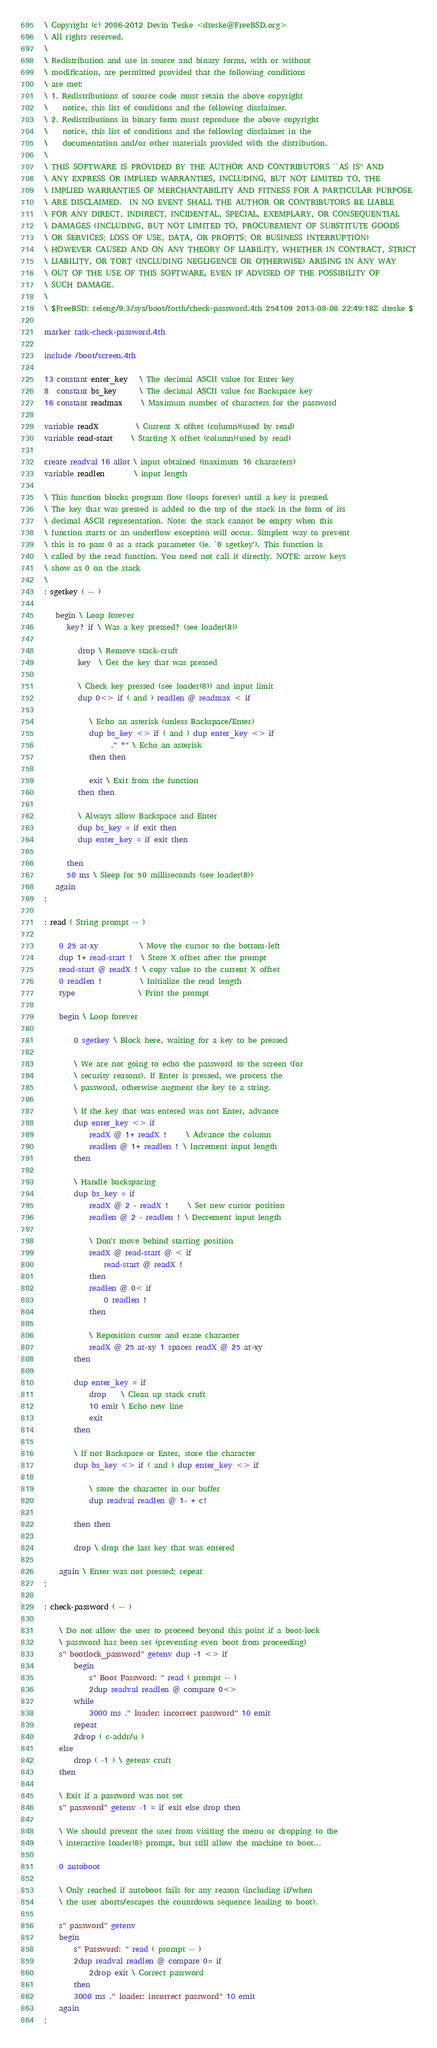Convert code to text. <code><loc_0><loc_0><loc_500><loc_500><_Forth_>\ Copyright (c) 2006-2012 Devin Teske <dteske@FreeBSD.org>
\ All rights reserved.
\ 
\ Redistribution and use in source and binary forms, with or without
\ modification, are permitted provided that the following conditions
\ are met:
\ 1. Redistributions of source code must retain the above copyright
\    notice, this list of conditions and the following disclaimer.
\ 2. Redistributions in binary form must reproduce the above copyright
\    notice, this list of conditions and the following disclaimer in the
\    documentation and/or other materials provided with the distribution.
\ 
\ THIS SOFTWARE IS PROVIDED BY THE AUTHOR AND CONTRIBUTORS ``AS IS'' AND
\ ANY EXPRESS OR IMPLIED WARRANTIES, INCLUDING, BUT NOT LIMITED TO, THE
\ IMPLIED WARRANTIES OF MERCHANTABILITY AND FITNESS FOR A PARTICULAR PURPOSE
\ ARE DISCLAIMED.  IN NO EVENT SHALL THE AUTHOR OR CONTRIBUTORS BE LIABLE
\ FOR ANY DIRECT, INDIRECT, INCIDENTAL, SPECIAL, EXEMPLARY, OR CONSEQUENTIAL
\ DAMAGES (INCLUDING, BUT NOT LIMITED TO, PROCUREMENT OF SUBSTITUTE GOODS
\ OR SERVICES; LOSS OF USE, DATA, OR PROFITS; OR BUSINESS INTERRUPTION)
\ HOWEVER CAUSED AND ON ANY THEORY OF LIABILITY, WHETHER IN CONTRACT, STRICT
\ LIABILITY, OR TORT (INCLUDING NEGLIGENCE OR OTHERWISE) ARISING IN ANY WAY
\ OUT OF THE USE OF THIS SOFTWARE, EVEN IF ADVISED OF THE POSSIBILITY OF
\ SUCH DAMAGE.
\ 
\ $FreeBSD: releng/9.3/sys/boot/forth/check-password.4th 254109 2013-08-08 22:49:18Z dteske $

marker task-check-password.4th

include /boot/screen.4th

13 constant enter_key   \ The decimal ASCII value for Enter key
8  constant bs_key      \ The decimal ASCII value for Backspace key
16 constant readmax     \ Maximum number of characters for the password

variable readX          \ Current X offset (column)(used by read)
variable read-start     \ Starting X offset (column)(used by read)

create readval 16 allot \ input obtained (maximum 16 characters)
variable readlen        \ input length

\ This function blocks program flow (loops forever) until a key is pressed.
\ The key that was pressed is added to the top of the stack in the form of its
\ decimal ASCII representation. Note: the stack cannot be empty when this
\ function starts or an underflow exception will occur. Simplest way to prevent
\ this is to pass 0 as a stack parameter (ie. `0 sgetkey'). This function is
\ called by the read function. You need not call it directly. NOTE: arrow keys
\ show as 0 on the stack
\ 
: sgetkey ( -- )

   begin \ Loop forever
      key? if \ Was a key pressed? (see loader(8))

         drop \ Remove stack-cruft
         key  \ Get the key that was pressed

         \ Check key pressed (see loader(8)) and input limit
         dup 0<> if ( and ) readlen @ readmax < if

            \ Echo an asterisk (unless Backspace/Enter)
            dup bs_key <> if ( and ) dup enter_key <> if
                  ." *" \ Echo an asterisk
            then then

            exit \ Exit from the function
         then then

         \ Always allow Backspace and Enter
         dup bs_key = if exit then
         dup enter_key = if exit then

      then
      50 ms \ Sleep for 50 milliseconds (see loader(8))
   again
;

: read ( String prompt -- )

	0 25 at-xy           \ Move the cursor to the bottom-left
	dup 1+ read-start !  \ Store X offset after the prompt
	read-start @ readX ! \ copy value to the current X offset
	0 readlen !          \ Initialize the read length
	type                 \ Print the prompt

	begin \ Loop forever

		0 sgetkey \ Block here, waiting for a key to be pressed

		\ We are not going to echo the password to the screen (for
		\ security reasons). If Enter is pressed, we process the
		\ password, otherwise augment the key to a string.

		\ If the key that was entered was not Enter, advance
		dup enter_key <> if
			readX @ 1+ readX !     \ Advance the column
			readlen @ 1+ readlen ! \ Increment input length
		then

		\ Handle backspacing
		dup bs_key = if
			readX @ 2 - readX !     \ Set new cursor position
			readlen @ 2 - readlen ! \ Decrement input length

			\ Don't move behind starting position
			readX @ read-start @ < if
				read-start @ readX !
			then
			readlen @ 0< if
				0 readlen !
			then

			\ Reposition cursor and erase character
			readX @ 25 at-xy 1 spaces readX @ 25 at-xy
		then

		dup enter_key = if
			drop    \ Clean up stack cruft
			10 emit \ Echo new line
			exit
		then

		\ If not Backspace or Enter, store the character
		dup bs_key <> if ( and ) dup enter_key <> if

			\ store the character in our buffer
			dup readval readlen @ 1- + c!

		then then

		drop \ drop the last key that was entered

	again \ Enter was not pressed; repeat
;

: check-password ( -- )

	\ Do not allow the user to proceed beyond this point if a boot-lock
	\ password has been set (preventing even boot from proceeding)
	s" bootlock_password" getenv dup -1 <> if
		begin
			s" Boot Password: " read ( prompt -- )
			2dup readval readlen @ compare 0<>
		while
			3000 ms ." loader: incorrect password" 10 emit
		repeat
		2drop ( c-addr/u )
	else
		drop ( -1 ) \ getenv cruft
	then

	\ Exit if a password was not set
	s" password" getenv -1 = if exit else drop then

	\ We should prevent the user from visiting the menu or dropping to the
	\ interactive loader(8) prompt, but still allow the machine to boot...

	0 autoboot

	\ Only reached if autoboot fails for any reason (including if/when
	\ the user aborts/escapes the countdown sequence leading to boot).

	s" password" getenv
	begin
		s" Password: " read ( prompt -- )
		2dup readval readlen @ compare 0= if
			2drop exit \ Correct password
		then
		3000 ms ." loader: incorrect password" 10 emit
	again
;
</code> 